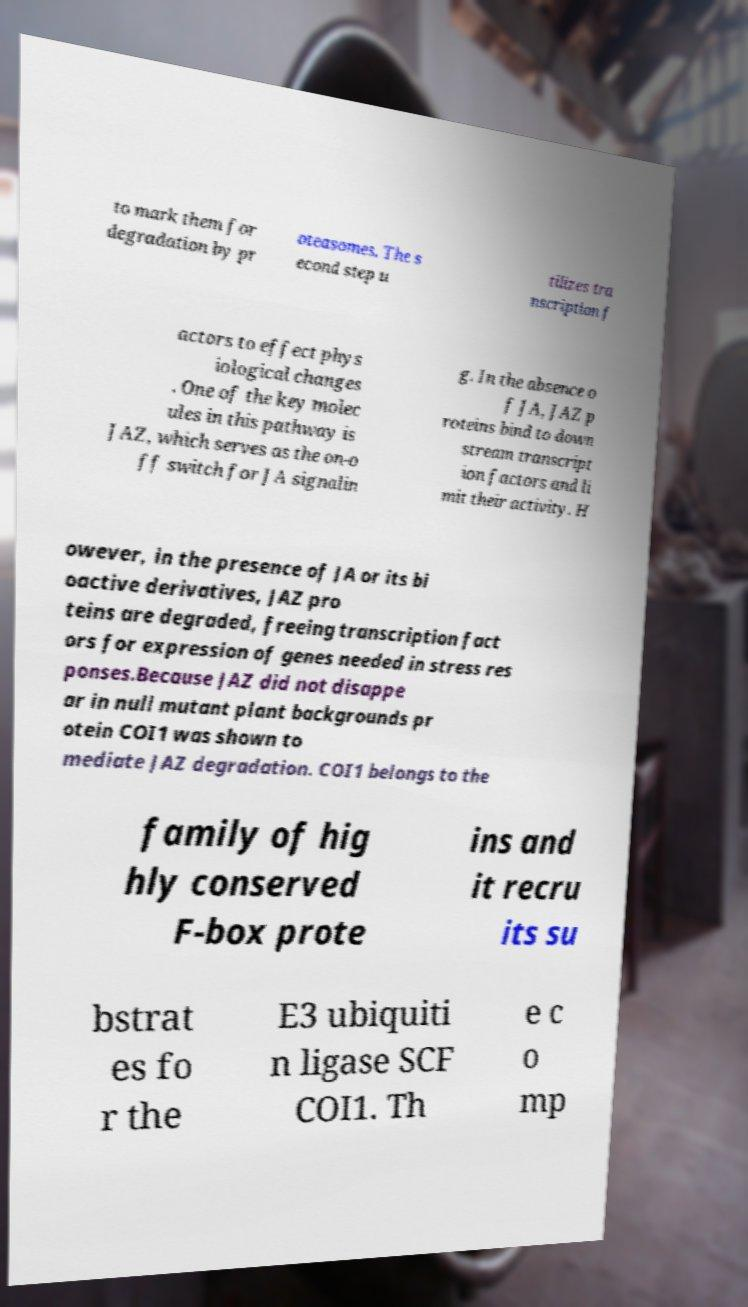There's text embedded in this image that I need extracted. Can you transcribe it verbatim? to mark them for degradation by pr oteasomes. The s econd step u tilizes tra nscription f actors to effect phys iological changes . One of the key molec ules in this pathway is JAZ, which serves as the on-o ff switch for JA signalin g. In the absence o f JA, JAZ p roteins bind to down stream transcript ion factors and li mit their activity. H owever, in the presence of JA or its bi oactive derivatives, JAZ pro teins are degraded, freeing transcription fact ors for expression of genes needed in stress res ponses.Because JAZ did not disappe ar in null mutant plant backgrounds pr otein COI1 was shown to mediate JAZ degradation. COI1 belongs to the family of hig hly conserved F-box prote ins and it recru its su bstrat es fo r the E3 ubiquiti n ligase SCF COI1. Th e c o mp 